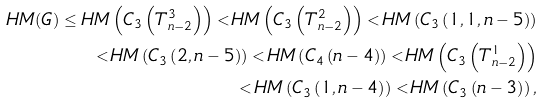Convert formula to latex. <formula><loc_0><loc_0><loc_500><loc_500>H M ( G ) \leq H M \left ( C _ { 3 } \left ( T ^ { 3 } _ { n - 2 } \right ) \right ) < H M \left ( C _ { 3 } \left ( T ^ { 2 } _ { n - 2 } \right ) \right ) < H M \left ( C _ { 3 } \left ( 1 , 1 , n - 5 \right ) \right ) \\ < H M \left ( C _ { 3 } \left ( 2 , n - 5 \right ) \right ) < H M \left ( C _ { 4 } \left ( n - 4 \right ) \right ) < H M \left ( C _ { 3 } \left ( T ^ { 1 } _ { n - 2 } \right ) \right ) \\ < H M \left ( C _ { 3 } \left ( 1 , n - 4 \right ) \right ) < H M \left ( C _ { 3 } \left ( n - 3 \right ) \right ) ,</formula> 